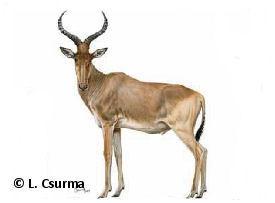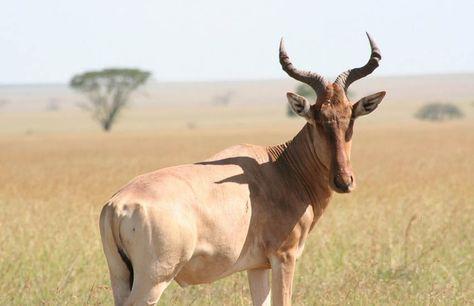The first image is the image on the left, the second image is the image on the right. For the images displayed, is the sentence "Each image contains just one horned animal, and the animals in the right and left images face away from each other." factually correct? Answer yes or no. Yes. 